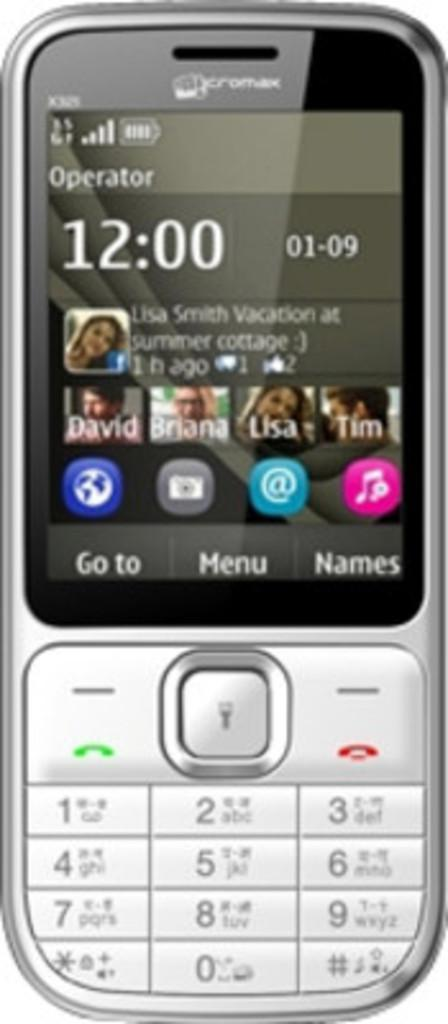<image>
Give a short and clear explanation of the subsequent image. A phone says that it is 12:00 on January 9th. 